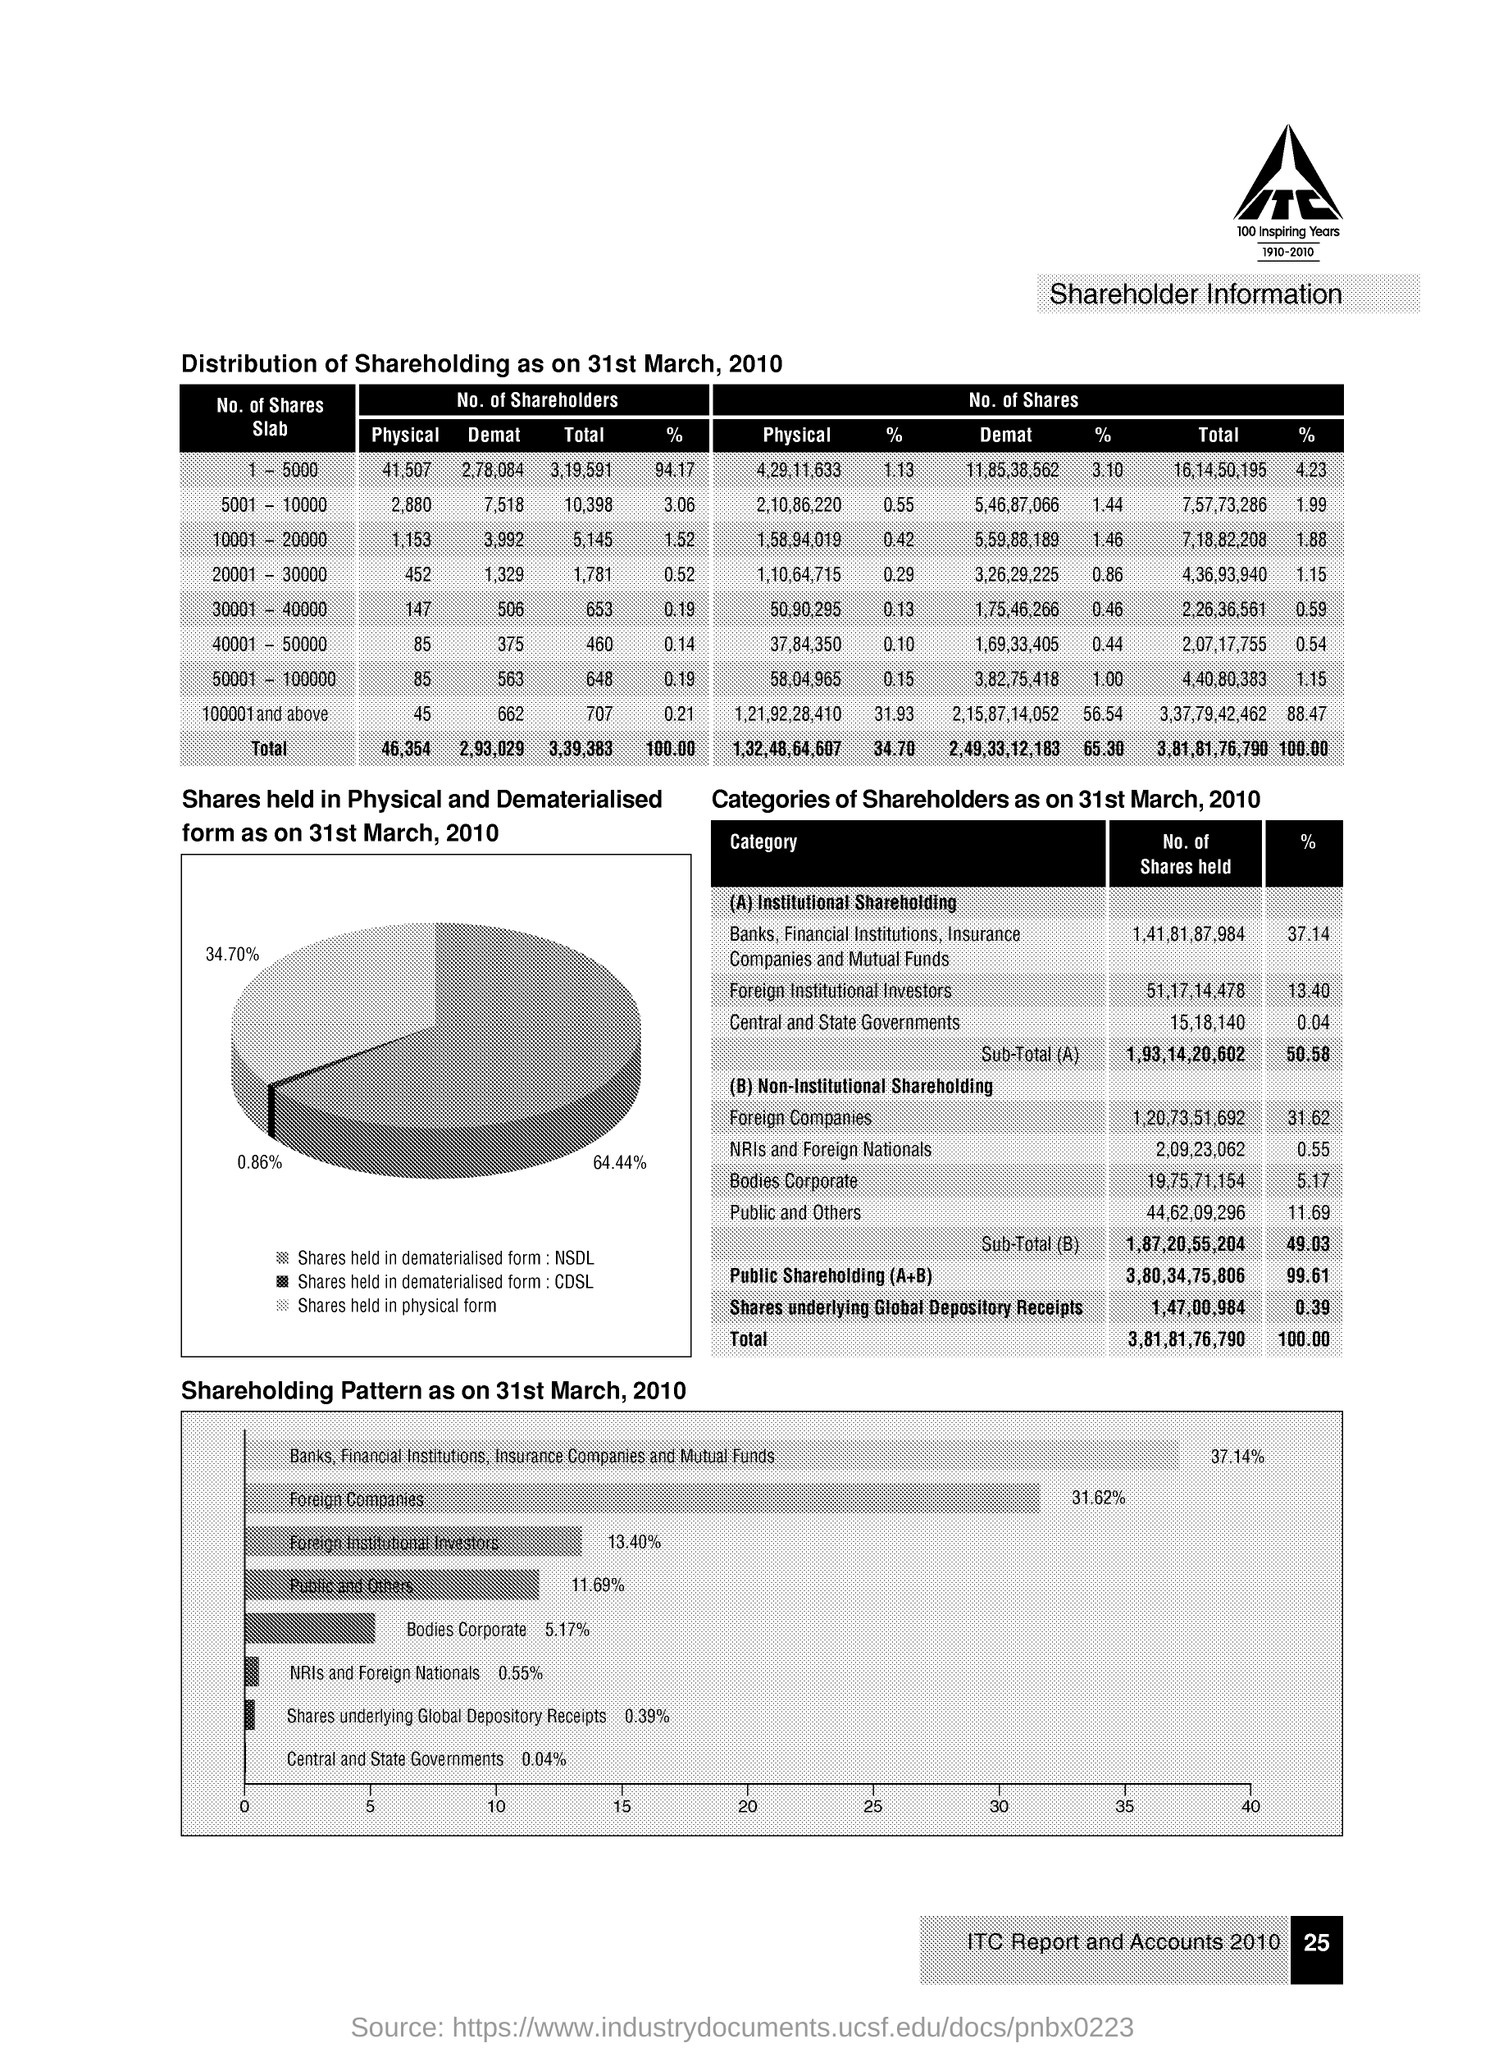Indicate a few pertinent items in this graphic. Approximately 37.14% of the shares are held by banks, financial institutions, insurance companies, and mutual funds. As of March 31, 2010, the percentage of foreign companies in the shareholding pattern was 31.62%. As of March 31st, 2010, the public and other shareholding pattern was 11.69%. The percentage of the total number of shares held by foreign institutional investors is 13.40%. As of March 31st, 2010, approximately 34.70% of the company's shares were held in physical form. 